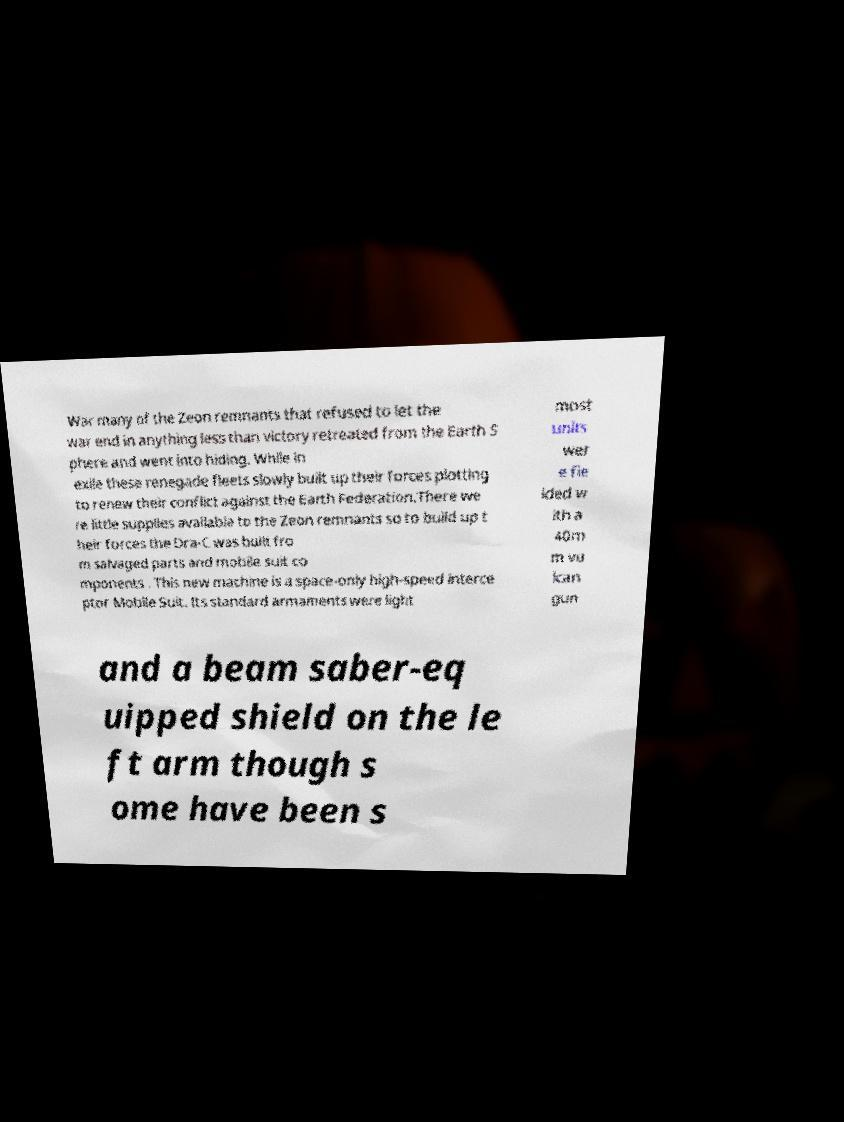Please identify and transcribe the text found in this image. War many of the Zeon remnants that refused to let the war end in anything less than victory retreated from the Earth S phere and went into hiding. While in exile these renegade fleets slowly built up their forces plotting to renew their conflict against the Earth Federation.There we re little supplies available to the Zeon remnants so to build up t heir forces the Dra-C was built fro m salvaged parts and mobile suit co mponents . This new machine is a space-only high-speed interce ptor Mobile Suit. Its standard armaments were light most units wer e fie lded w ith a 40m m vu lcan gun and a beam saber-eq uipped shield on the le ft arm though s ome have been s 